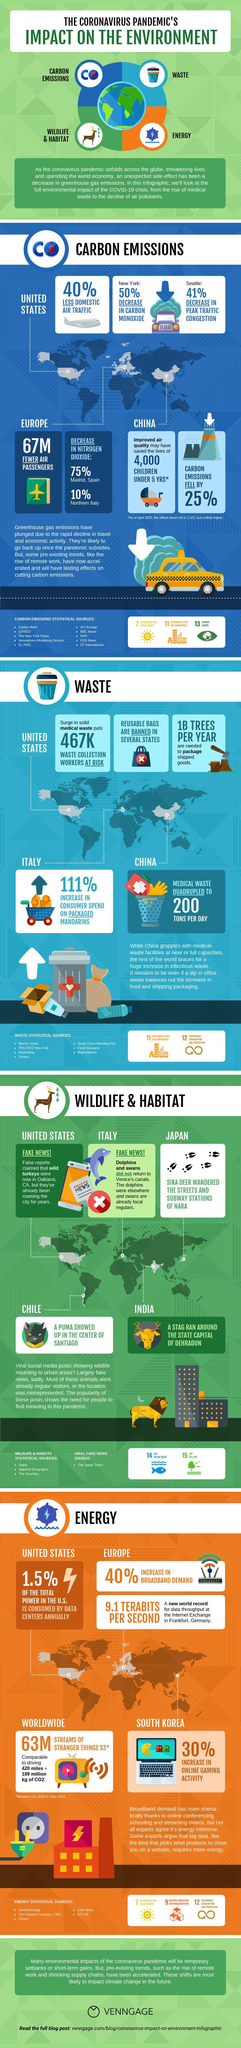How many times was stranger things season 3 streamed worldwide?
Answer the question with a short phrase. 63M What percentage of air traffic did United States see during the coronavirus pandemic? 60% How much reduction in Nitrogen Dioxide did Northern Italy see during the coronavirus pandemic? 10% How much reduction in carbon monoxide did New York see during the coronavirus pandemic? 50% What is the average number of waste collection workers in the United States? 467k What sort of waste saw a reduction during the coronavirus pandemic? office waste What amount of electricity do the data centers in the United States use annually? 1.5% How much increase in online gaming activity did South Korea see during the coronavirus pandemic? 30% Where was the new world record for the data throughput recorded? Internet exchange in Frankfurt,Germany How much increase in percentage in Medical waste did China see during the coronavirus pandemic? 400% What factors have the probability to impact climate change in future? rise of remote work,shrinking supply chains How much reduction in Nitrogen Dioxide did Madrid, Spain see during the coronavirus pandemic? 75% 